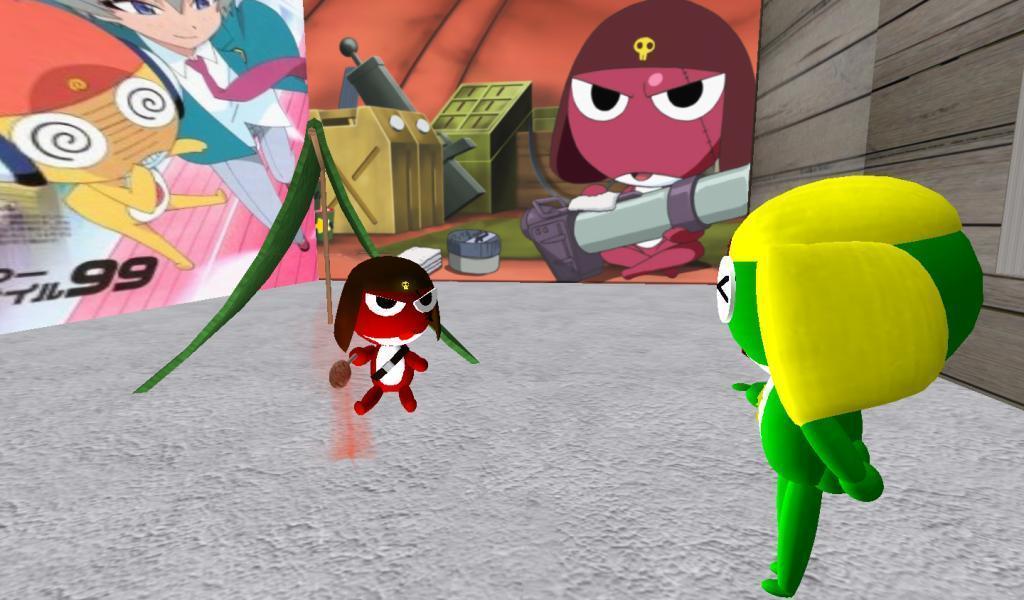How would you summarize this image in a sentence or two? This is an animation picture. In this image there are toys. At the back there are boards and there are pictures of a cartons and boxes on the on the board. 